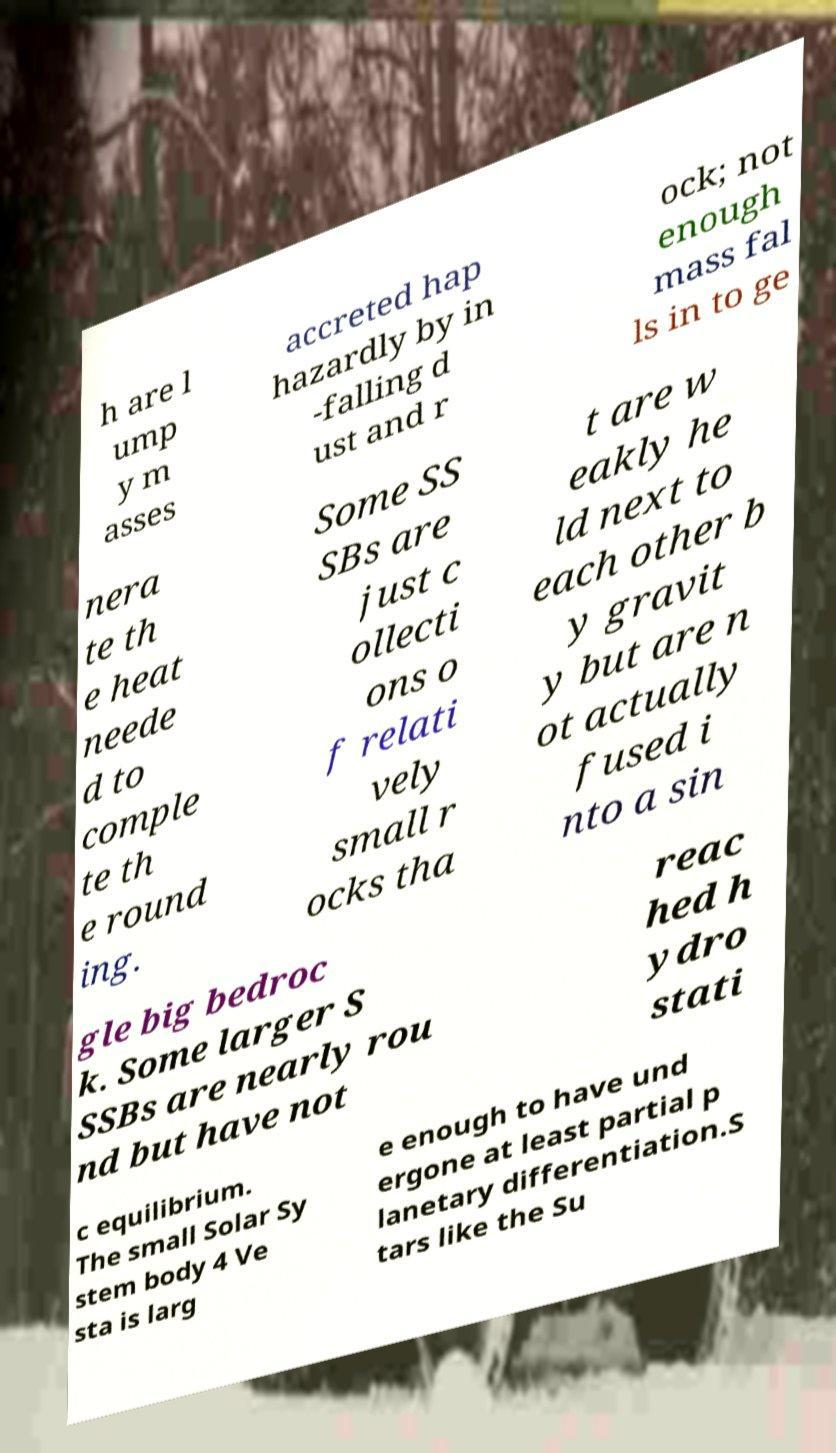Please identify and transcribe the text found in this image. h are l ump y m asses accreted hap hazardly by in -falling d ust and r ock; not enough mass fal ls in to ge nera te th e heat neede d to comple te th e round ing. Some SS SBs are just c ollecti ons o f relati vely small r ocks tha t are w eakly he ld next to each other b y gravit y but are n ot actually fused i nto a sin gle big bedroc k. Some larger S SSBs are nearly rou nd but have not reac hed h ydro stati c equilibrium. The small Solar Sy stem body 4 Ve sta is larg e enough to have und ergone at least partial p lanetary differentiation.S tars like the Su 